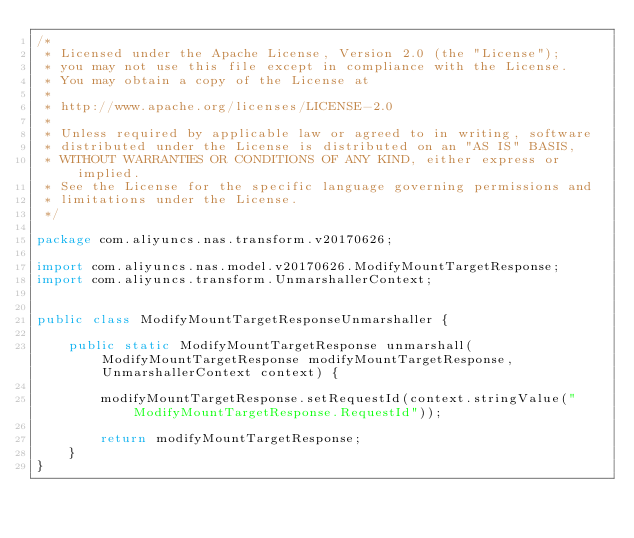<code> <loc_0><loc_0><loc_500><loc_500><_Java_>/*
 * Licensed under the Apache License, Version 2.0 (the "License");
 * you may not use this file except in compliance with the License.
 * You may obtain a copy of the License at
 *
 * http://www.apache.org/licenses/LICENSE-2.0
 *
 * Unless required by applicable law or agreed to in writing, software
 * distributed under the License is distributed on an "AS IS" BASIS,
 * WITHOUT WARRANTIES OR CONDITIONS OF ANY KIND, either express or implied.
 * See the License for the specific language governing permissions and
 * limitations under the License.
 */

package com.aliyuncs.nas.transform.v20170626;

import com.aliyuncs.nas.model.v20170626.ModifyMountTargetResponse;
import com.aliyuncs.transform.UnmarshallerContext;


public class ModifyMountTargetResponseUnmarshaller {

	public static ModifyMountTargetResponse unmarshall(ModifyMountTargetResponse modifyMountTargetResponse, UnmarshallerContext context) {
		
		modifyMountTargetResponse.setRequestId(context.stringValue("ModifyMountTargetResponse.RequestId"));
	 
	 	return modifyMountTargetResponse;
	}
}</code> 